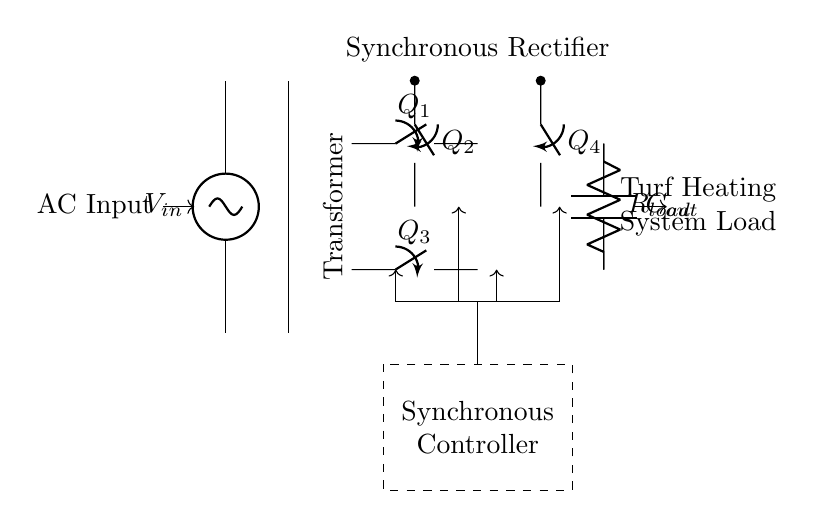What is the input voltage source labeled in the circuit? The circuit diagram labels the input voltage source as \( V_{in} \), which indicates the voltage being supplied to the rectifier.
Answer: V_in How many synchronous switches are used in the rectifier? The diagram shows four synchronous switches labeled \( Q_1 \), \( Q_2 \), \( Q_3 \), and \( Q_4 \), indicating that there are four synchronous switches used in total.
Answer: Four What is the function of the rectangular dashed box in the circuit? The rectangular dashed box indicates the synchronous controller, which manages the operation of the synchronous switches to optimize power conversion.
Answer: Synchronous controller What type of load is connected to the output of the circuit? The output is connected to a load labeled as \( R_{load} \), which is typically a resistive load in heating applications like turf heating systems.
Answer: Resistor Which component helps smooth out the output voltage? The component labeled \( C_{out} \) in the circuit is a capacitor that helps smooth out the output voltage by filtering any fluctuations.
Answer: Capacitor What is the purpose of the transformer in this circuit? The transformer in the circuit is responsible for stepping up or stepping down the AC input voltage before it is converted to DC by the synchronous rectifiers.
Answer: Voltage transformation How do the control signals in the circuit affect the synchronous switches? The control signals, represented by arrows leading to the synchronous switches, dictate when each switch turns on or off, ensuring efficient rectification during both halves of the AC cycle.
Answer: Control signals manage switches 